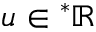Convert formula to latex. <formula><loc_0><loc_0><loc_500><loc_500>u ^ { \ast } \mathbb { R }</formula> 